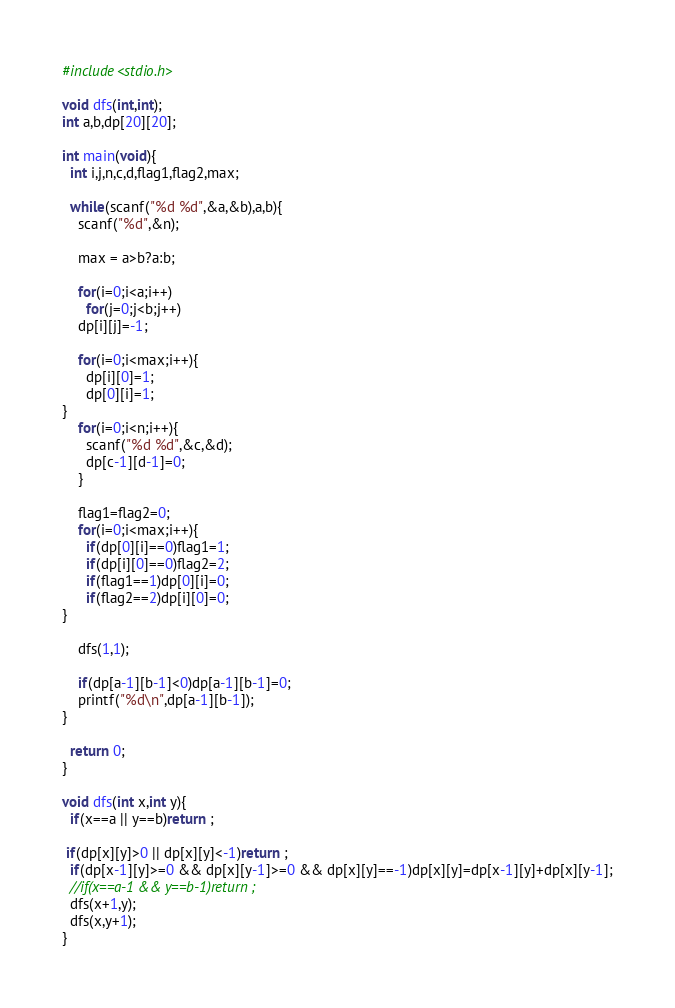Convert code to text. <code><loc_0><loc_0><loc_500><loc_500><_C_>#include<stdio.h>

void dfs(int,int);
int a,b,dp[20][20];

int main(void){
  int i,j,n,c,d,flag1,flag2,max;

  while(scanf("%d %d",&a,&b),a,b){
    scanf("%d",&n);

    max = a>b?a:b;

    for(i=0;i<a;i++)
      for(j=0;j<b;j++)
	dp[i][j]=-1;

    for(i=0;i<max;i++){
      dp[i][0]=1;
      dp[0][i]=1;
}
    for(i=0;i<n;i++){
      scanf("%d %d",&c,&d);
      dp[c-1][d-1]=0;
    }

    flag1=flag2=0;
    for(i=0;i<max;i++){
      if(dp[0][i]==0)flag1=1;
      if(dp[i][0]==0)flag2=2;
      if(flag1==1)dp[0][i]=0;
      if(flag2==2)dp[i][0]=0;
}

    dfs(1,1);

    if(dp[a-1][b-1]<0)dp[a-1][b-1]=0;
    printf("%d\n",dp[a-1][b-1]);
}

  return 0;
}

void dfs(int x,int y){
  if(x==a || y==b)return ;

 if(dp[x][y]>0 || dp[x][y]<-1)return ;
  if(dp[x-1][y]>=0 && dp[x][y-1]>=0 && dp[x][y]==-1)dp[x][y]=dp[x-1][y]+dp[x][y-1];
  //if(x==a-1 && y==b-1)return ;
  dfs(x+1,y);
  dfs(x,y+1);
}</code> 